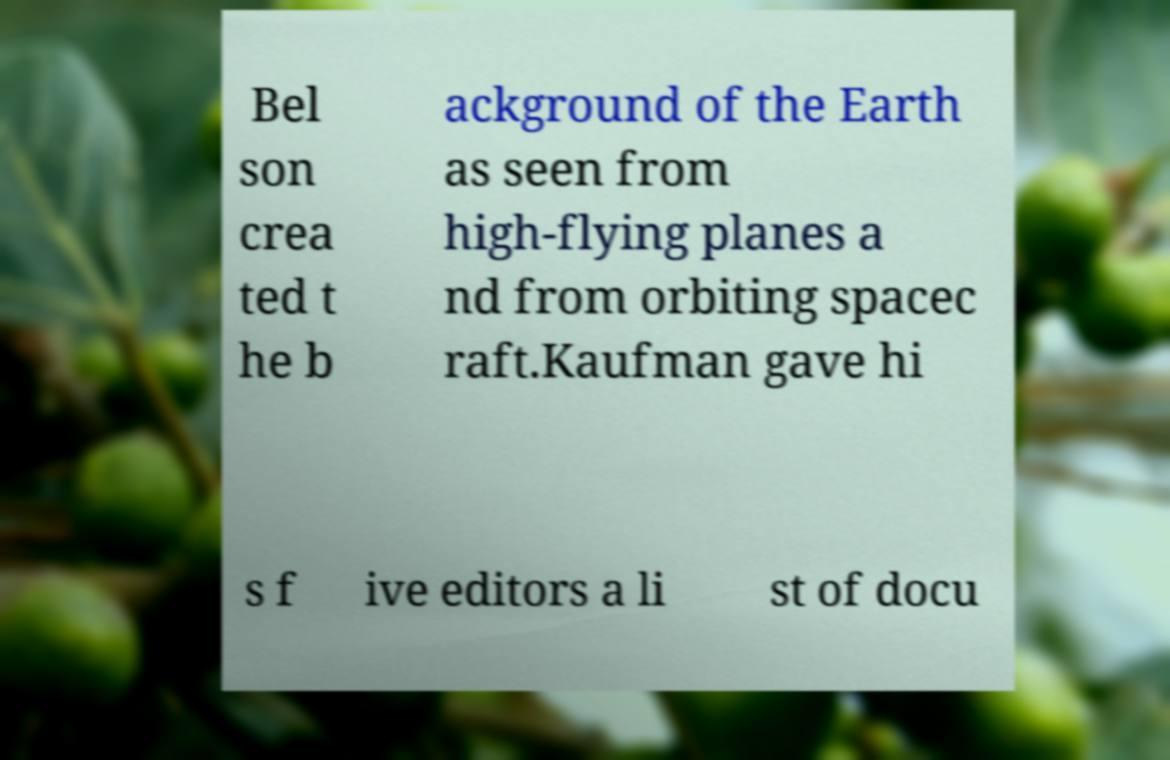There's text embedded in this image that I need extracted. Can you transcribe it verbatim? Bel son crea ted t he b ackground of the Earth as seen from high-flying planes a nd from orbiting spacec raft.Kaufman gave hi s f ive editors a li st of docu 